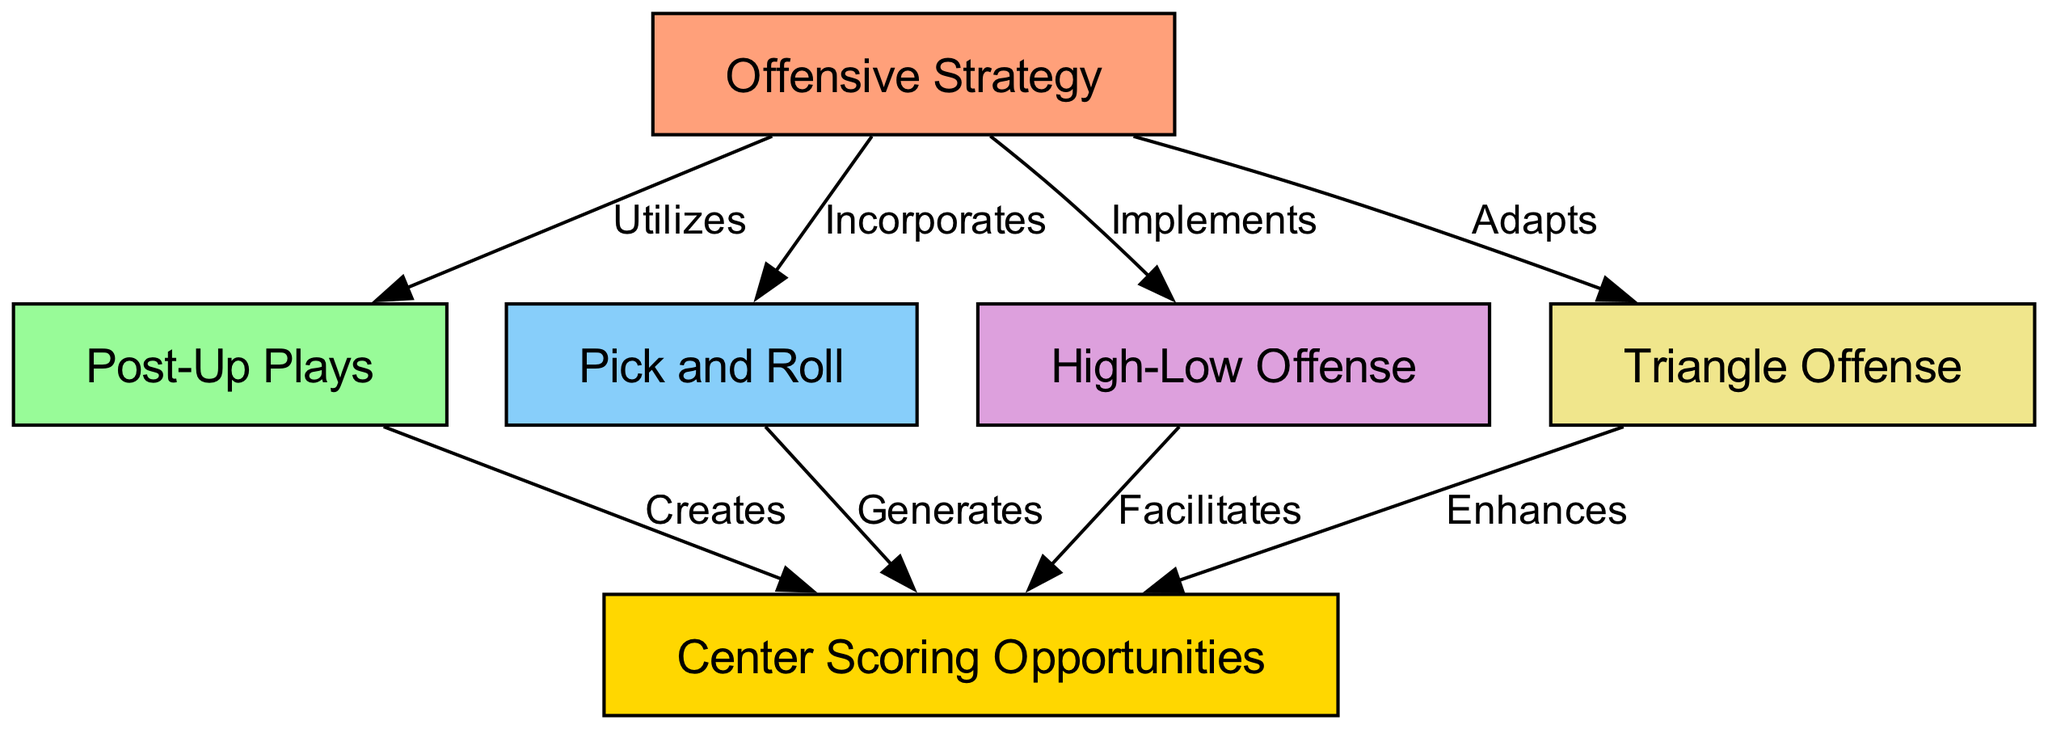What is the main node in the diagram? The main node labeled "Offensive Strategy" is at the top of the diagram, indicating it is the central concept.
Answer: Offensive Strategy How many offensive strategies are shown? There are four offensive strategies branching from the "Offensive Strategy" node: Post-Up Plays, Pick and Roll, High-Low Offense, and Triangle Offense.
Answer: 4 Which strategy creates center scoring opportunities? The "Post-Up Plays" node directly creates center scoring opportunities as shown by the edge labeled "Creates."
Answer: Post-Up Plays What strategy enhances center scoring opportunities? The "Triangle Offense" is indicated to enhance center scoring opportunities as shown by the directed edge labeled "Enhances."
Answer: Triangle Offense Which offensive strategy incorporates another strategy? The "Pick and Roll" is incorporated into the main "Offensive Strategy," suggesting it is used within that framework.
Answer: Pick and Roll How many nodes connect to "Center Scoring Opportunities"? There are four nodes that connect to "Center Scoring Opportunities": Post-Up Plays, Pick and Roll, High-Low Offense, and Triangle Offense.
Answer: 4 What labels describe the relationships between the offensive strategies and center scoring opportunities? The relationships are described with the following labels: Creates, Generates, Facilitates, and Enhances.
Answer: Creates, Generates, Facilitates, Enhances What is the relationship type from "High-Low Offense" to "Center Scoring Opportunities"? The relationship from "High-Low Offense" to "Center Scoring Opportunities" is labeled "Facilitates," indicating it aids in that scoring potential.
Answer: Facilitates Which offensive strategy is shown to implement strategies? The node "High-Low Offense" implements strategies under the main node "Offensive Strategy."
Answer: High-Low Offense 